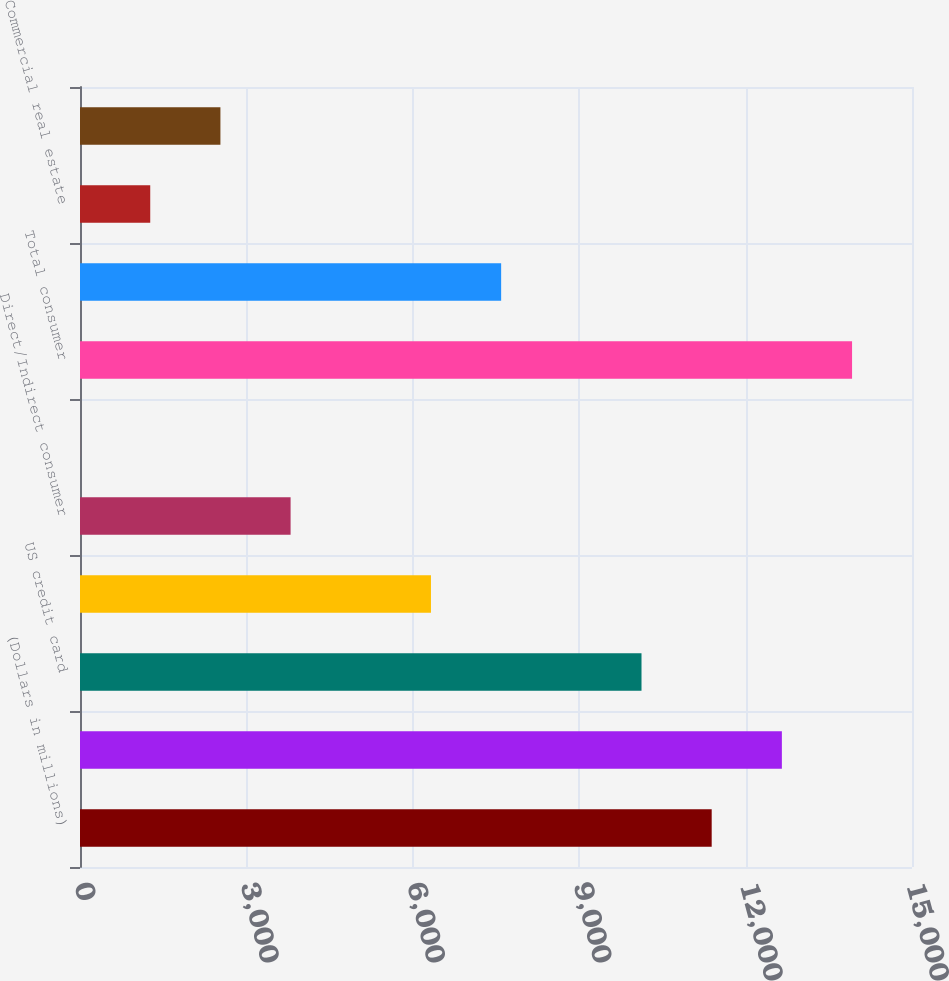Convert chart to OTSL. <chart><loc_0><loc_0><loc_500><loc_500><bar_chart><fcel>(Dollars in millions)<fcel>Residential mortgage (2)<fcel>US credit card<fcel>Non-US credit card<fcel>Direct/Indirect consumer<fcel>Other consumer<fcel>Total consumer<fcel>US commercial<fcel>Commercial real estate<fcel>Commercial lease financing<nl><fcel>11388.7<fcel>12654<fcel>10123.4<fcel>6327.5<fcel>3796.9<fcel>1<fcel>13919.3<fcel>7592.8<fcel>1266.3<fcel>2531.6<nl></chart> 